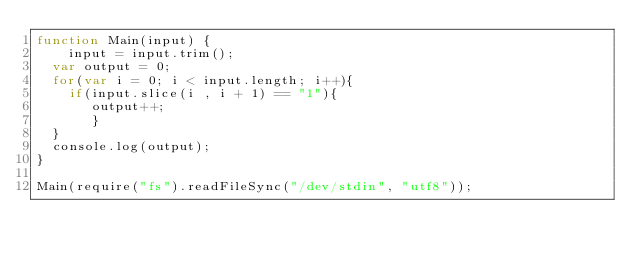<code> <loc_0><loc_0><loc_500><loc_500><_JavaScript_>function Main(input) {
	input = input.trim();
  var output = 0;
  for(var i = 0; i < input.length; i++){
    if(input.slice(i , i + 1) == "1"){
       output++;
       }
  }
  console.log(output);
}

Main(require("fs").readFileSync("/dev/stdin", "utf8"));
</code> 